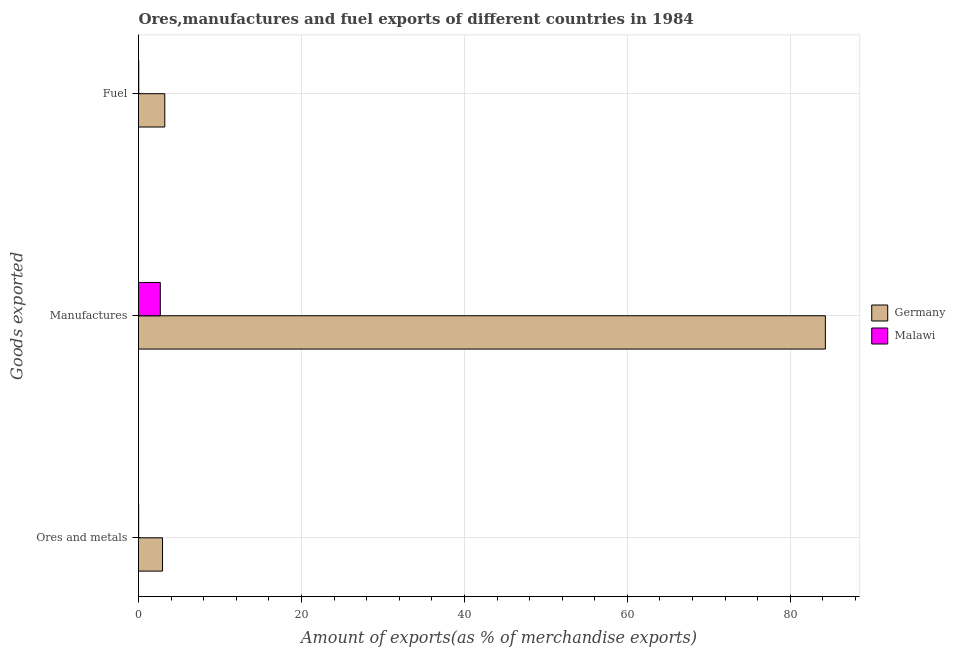Are the number of bars per tick equal to the number of legend labels?
Keep it short and to the point. Yes. How many bars are there on the 3rd tick from the top?
Your answer should be very brief. 2. How many bars are there on the 1st tick from the bottom?
Offer a terse response. 2. What is the label of the 2nd group of bars from the top?
Provide a short and direct response. Manufactures. What is the percentage of fuel exports in Malawi?
Your response must be concise. 0.03. Across all countries, what is the maximum percentage of manufactures exports?
Your response must be concise. 84.3. Across all countries, what is the minimum percentage of ores and metals exports?
Your response must be concise. 0.02. In which country was the percentage of manufactures exports minimum?
Keep it short and to the point. Malawi. What is the total percentage of ores and metals exports in the graph?
Offer a terse response. 2.97. What is the difference between the percentage of ores and metals exports in Malawi and that in Germany?
Provide a short and direct response. -2.93. What is the difference between the percentage of ores and metals exports in Germany and the percentage of manufactures exports in Malawi?
Keep it short and to the point. 0.27. What is the average percentage of fuel exports per country?
Your response must be concise. 1.63. What is the difference between the percentage of fuel exports and percentage of manufactures exports in Germany?
Your answer should be compact. -81.07. What is the ratio of the percentage of manufactures exports in Germany to that in Malawi?
Make the answer very short. 31.49. What is the difference between the highest and the second highest percentage of ores and metals exports?
Make the answer very short. 2.93. What is the difference between the highest and the lowest percentage of manufactures exports?
Provide a succinct answer. 81.62. Is the sum of the percentage of ores and metals exports in Germany and Malawi greater than the maximum percentage of fuel exports across all countries?
Keep it short and to the point. No. What does the 2nd bar from the top in Manufactures represents?
Offer a very short reply. Germany. What does the 2nd bar from the bottom in Fuel represents?
Your response must be concise. Malawi. Is it the case that in every country, the sum of the percentage of ores and metals exports and percentage of manufactures exports is greater than the percentage of fuel exports?
Your answer should be compact. Yes. Are all the bars in the graph horizontal?
Provide a succinct answer. Yes. What is the difference between two consecutive major ticks on the X-axis?
Offer a very short reply. 20. Where does the legend appear in the graph?
Ensure brevity in your answer.  Center right. How many legend labels are there?
Your answer should be compact. 2. How are the legend labels stacked?
Your answer should be very brief. Vertical. What is the title of the graph?
Your answer should be compact. Ores,manufactures and fuel exports of different countries in 1984. What is the label or title of the X-axis?
Your response must be concise. Amount of exports(as % of merchandise exports). What is the label or title of the Y-axis?
Provide a short and direct response. Goods exported. What is the Amount of exports(as % of merchandise exports) of Germany in Ores and metals?
Provide a succinct answer. 2.95. What is the Amount of exports(as % of merchandise exports) of Malawi in Ores and metals?
Your response must be concise. 0.02. What is the Amount of exports(as % of merchandise exports) in Germany in Manufactures?
Keep it short and to the point. 84.3. What is the Amount of exports(as % of merchandise exports) in Malawi in Manufactures?
Offer a terse response. 2.68. What is the Amount of exports(as % of merchandise exports) in Germany in Fuel?
Offer a very short reply. 3.23. What is the Amount of exports(as % of merchandise exports) in Malawi in Fuel?
Provide a short and direct response. 0.03. Across all Goods exported, what is the maximum Amount of exports(as % of merchandise exports) in Germany?
Make the answer very short. 84.3. Across all Goods exported, what is the maximum Amount of exports(as % of merchandise exports) in Malawi?
Make the answer very short. 2.68. Across all Goods exported, what is the minimum Amount of exports(as % of merchandise exports) in Germany?
Your answer should be very brief. 2.95. Across all Goods exported, what is the minimum Amount of exports(as % of merchandise exports) of Malawi?
Give a very brief answer. 0.02. What is the total Amount of exports(as % of merchandise exports) of Germany in the graph?
Your response must be concise. 90.48. What is the total Amount of exports(as % of merchandise exports) in Malawi in the graph?
Offer a terse response. 2.72. What is the difference between the Amount of exports(as % of merchandise exports) in Germany in Ores and metals and that in Manufactures?
Provide a succinct answer. -81.35. What is the difference between the Amount of exports(as % of merchandise exports) of Malawi in Ores and metals and that in Manufactures?
Give a very brief answer. -2.66. What is the difference between the Amount of exports(as % of merchandise exports) in Germany in Ores and metals and that in Fuel?
Keep it short and to the point. -0.28. What is the difference between the Amount of exports(as % of merchandise exports) of Malawi in Ores and metals and that in Fuel?
Offer a very short reply. -0.01. What is the difference between the Amount of exports(as % of merchandise exports) in Germany in Manufactures and that in Fuel?
Your response must be concise. 81.07. What is the difference between the Amount of exports(as % of merchandise exports) of Malawi in Manufactures and that in Fuel?
Offer a terse response. 2.65. What is the difference between the Amount of exports(as % of merchandise exports) of Germany in Ores and metals and the Amount of exports(as % of merchandise exports) of Malawi in Manufactures?
Make the answer very short. 0.27. What is the difference between the Amount of exports(as % of merchandise exports) of Germany in Ores and metals and the Amount of exports(as % of merchandise exports) of Malawi in Fuel?
Make the answer very short. 2.92. What is the difference between the Amount of exports(as % of merchandise exports) in Germany in Manufactures and the Amount of exports(as % of merchandise exports) in Malawi in Fuel?
Ensure brevity in your answer.  84.27. What is the average Amount of exports(as % of merchandise exports) in Germany per Goods exported?
Your answer should be very brief. 30.16. What is the average Amount of exports(as % of merchandise exports) of Malawi per Goods exported?
Make the answer very short. 0.91. What is the difference between the Amount of exports(as % of merchandise exports) of Germany and Amount of exports(as % of merchandise exports) of Malawi in Ores and metals?
Provide a short and direct response. 2.93. What is the difference between the Amount of exports(as % of merchandise exports) in Germany and Amount of exports(as % of merchandise exports) in Malawi in Manufactures?
Your response must be concise. 81.62. What is the difference between the Amount of exports(as % of merchandise exports) in Germany and Amount of exports(as % of merchandise exports) in Malawi in Fuel?
Keep it short and to the point. 3.2. What is the ratio of the Amount of exports(as % of merchandise exports) in Germany in Ores and metals to that in Manufactures?
Ensure brevity in your answer.  0.04. What is the ratio of the Amount of exports(as % of merchandise exports) of Malawi in Ores and metals to that in Manufactures?
Your answer should be very brief. 0.01. What is the ratio of the Amount of exports(as % of merchandise exports) of Germany in Ores and metals to that in Fuel?
Your answer should be compact. 0.91. What is the ratio of the Amount of exports(as % of merchandise exports) in Malawi in Ores and metals to that in Fuel?
Your answer should be compact. 0.58. What is the ratio of the Amount of exports(as % of merchandise exports) in Germany in Manufactures to that in Fuel?
Make the answer very short. 26.13. What is the ratio of the Amount of exports(as % of merchandise exports) in Malawi in Manufactures to that in Fuel?
Your response must be concise. 92.51. What is the difference between the highest and the second highest Amount of exports(as % of merchandise exports) in Germany?
Give a very brief answer. 81.07. What is the difference between the highest and the second highest Amount of exports(as % of merchandise exports) of Malawi?
Your response must be concise. 2.65. What is the difference between the highest and the lowest Amount of exports(as % of merchandise exports) of Germany?
Keep it short and to the point. 81.35. What is the difference between the highest and the lowest Amount of exports(as % of merchandise exports) in Malawi?
Provide a short and direct response. 2.66. 